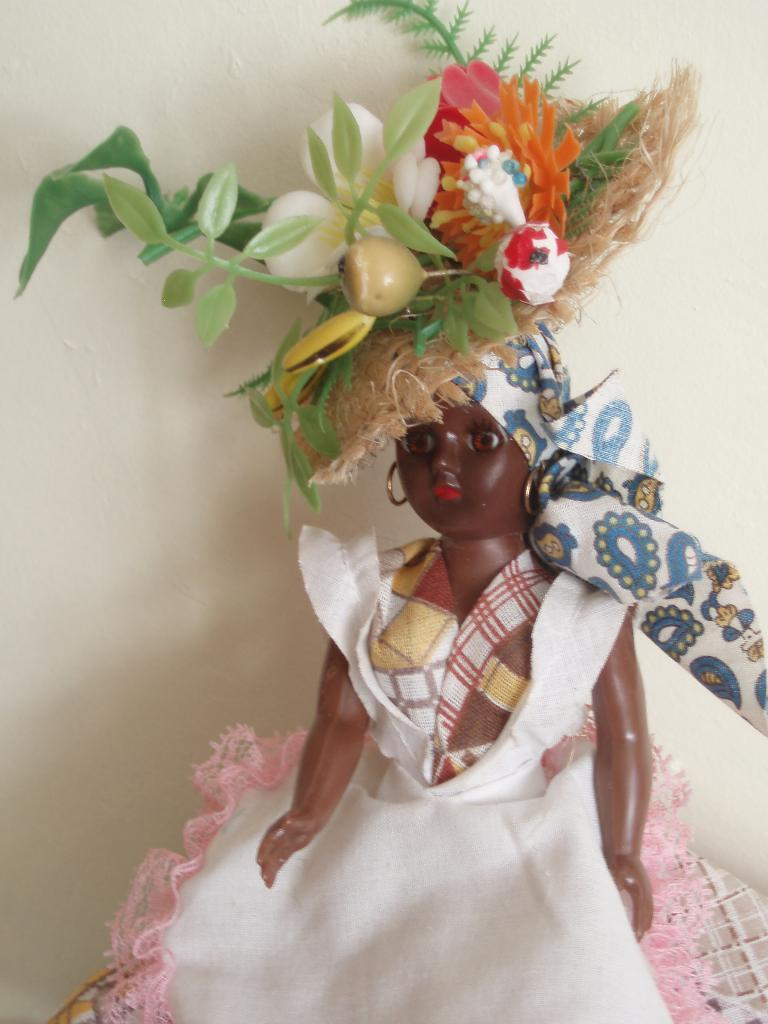What is the color of the doll in the image? The doll is brown colored. What is the doll wearing in the image? The doll is wearing a white dress. What accessory does the doll have on its head? The doll has a big hat. How is the hat decorated? The hat has flowers and leaves decorated on it. How many pigs are visible in the image? There are no pigs present in the image. What type of desk can be seen in the image? There is no desk present in the image. 